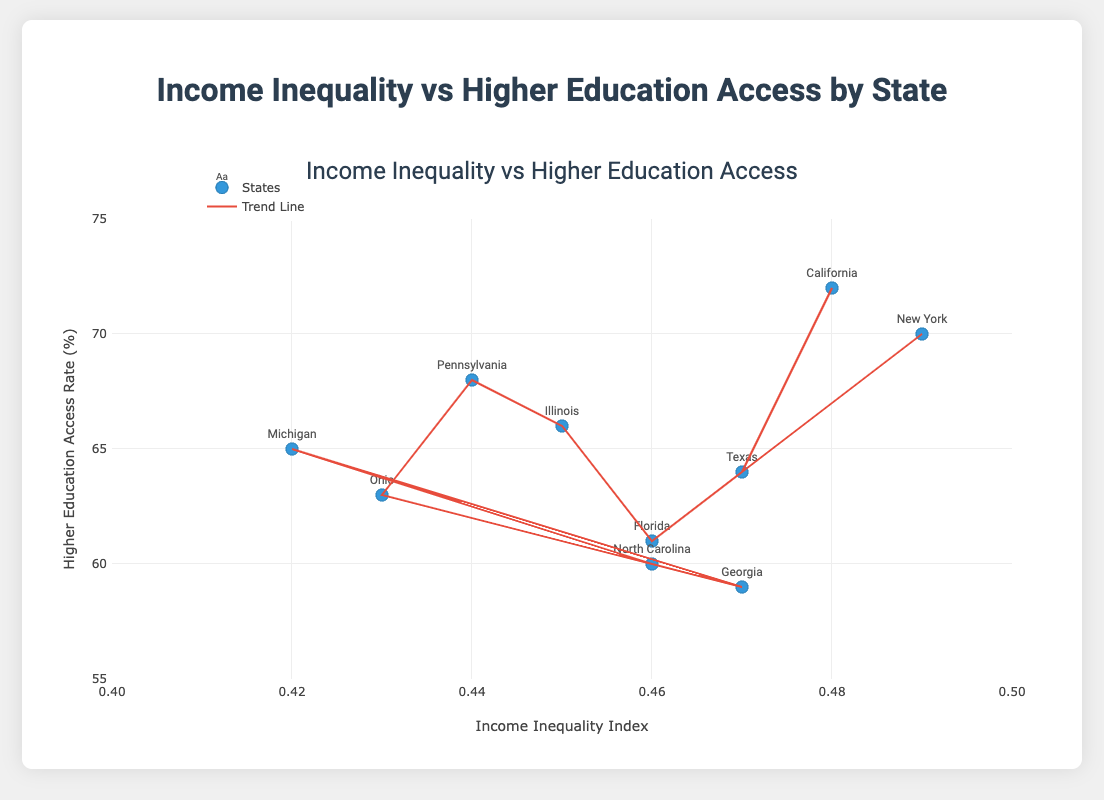What is the title of the scatter plot? The title is usually displayed at the top of the figure. In this case, the title is clearly written above the chart.
Answer: Income Inequality vs Higher Education Access by State What does the x-axis represent? The x-axis represents the horizontal axis that typically contains information about one of the variables in the scatter plot. In this figure, it represents the Income Inequality Index.
Answer: Income Inequality Index Which state has the highest access rate to higher education? To find the state with the highest education access rate, we look for the highest point on the y-axis and identify the state label associated with it.
Answer: California Is there a general trend between income inequality and access to higher education? A trend line has been plotted to show the overall direction of the data points. By observing the trend line, we can identify if there's a positive, negative, or no correlation.
Answer: Positive correlation How does Georgia compare to Ohio in terms of income inequality and higher education access rate? To answer this, compare the data points of Georgia and Ohio for their positions on both axes. Georgia has an income inequality index of 0.47 and an access rate of 59%, while Ohio has 0.43 and 63%.
Answer: Georgia has higher inequality and lower access rate than Ohio How many states are represented in the scatter plot? The scatter plot includes individual data points for each state. Counting the number of different state labels gives the total number of states.
Answer: 10 Which state has the lowest income inequality index? The state with the lowest income inequality index will have its data point furthest to the left on the x-axis. The label associated with this point will indicate the state.
Answer: Michigan What's the difference in the higher education access rate between Pennsylvania and North Carolina? To find the difference, subtract the higher education access rate of North Carolina from that of Pennsylvania (68% - 60%).
Answer: 8% What is the average income inequality index of the states shown in the scatter plot? Adding up all the income inequality indices and dividing by the number of states (10), the calculation is (0.48 + 0.47 + 0.49 + 0.46 + 0.45 + 0.44 + 0.43 + 0.47 + 0.42 + 0.46)/10 = 4.57/10
Answer: 0.457 Does Texas have a lower or higher higher education access rate compared to the average of all states shown? First, calculate the average higher education access rate for all states. Sum their rates and divide by the number of states (10). Then, compare the calculated average against Texas's rate (64%). The sum of rates is (72 + 64 + 70 + 61 + 66 + 68 + 63 + 59 + 65 + 60) = 648. The average is 648/10 = 64.8.
Answer: Lower 